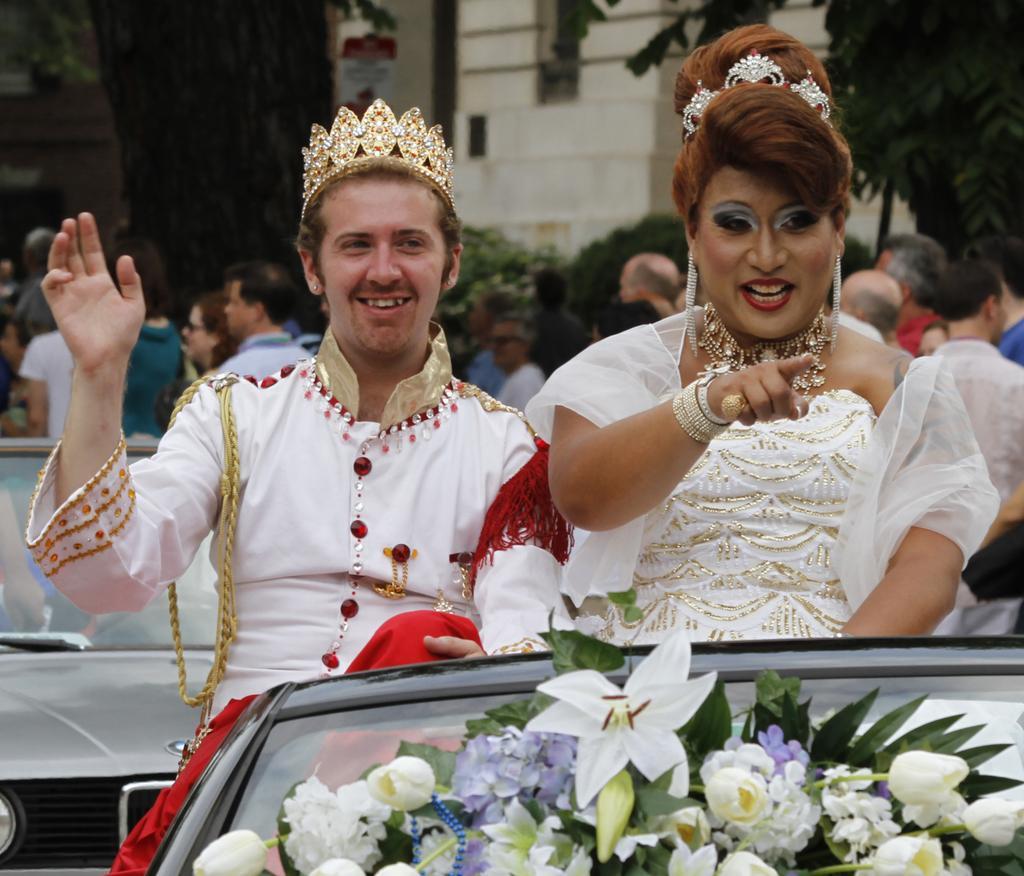Could you give a brief overview of what you see in this image? In this image we can see two persons in the vehicle, on the vehicle, there are some flowers, also we can see a vehicle and few people, there are some buildings, trees and a board with some text. 